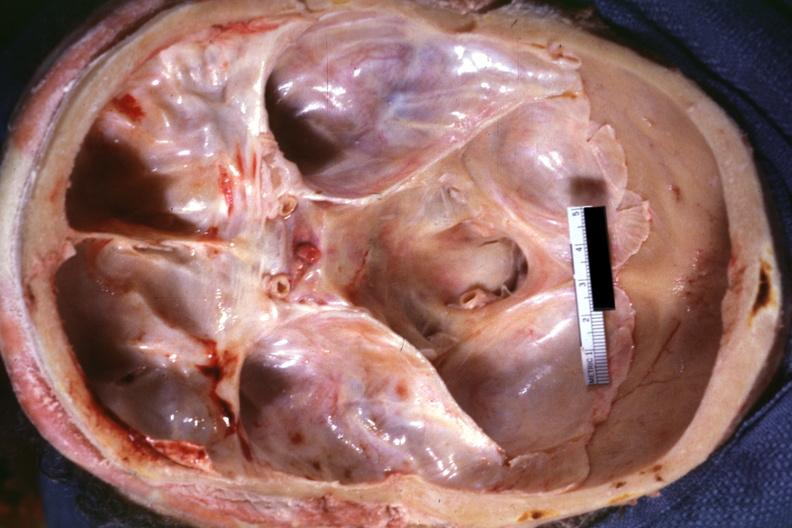does this image show view into foramen magnum marked narrowing due to subluxation odontoid process second cervical vertebra?
Answer the question using a single word or phrase. Yes 